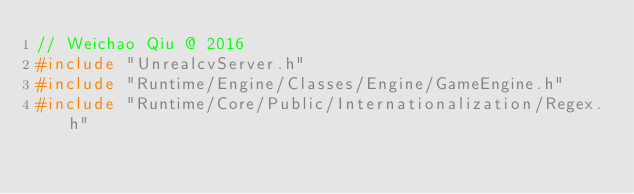Convert code to text. <code><loc_0><loc_0><loc_500><loc_500><_C++_>// Weichao Qiu @ 2016
#include "UnrealcvServer.h"
#include "Runtime/Engine/Classes/Engine/GameEngine.h"
#include "Runtime/Core/Public/Internationalization/Regex.h"</code> 